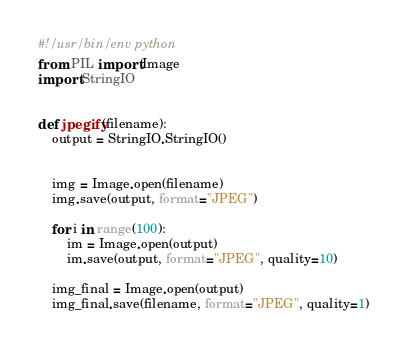<code> <loc_0><loc_0><loc_500><loc_500><_Python_>#!/usr/bin/env python
from PIL import Image
import StringIO


def jpegify(filename):
    output = StringIO.StringIO()
 

    img = Image.open(filename)
    img.save(output, format="JPEG")

    for i in range(100):
        im = Image.open(output)
        im.save(output, format="JPEG", quality=10)

    img_final = Image.open(output)
    img_final.save(filename, format="JPEG", quality=1)
</code> 